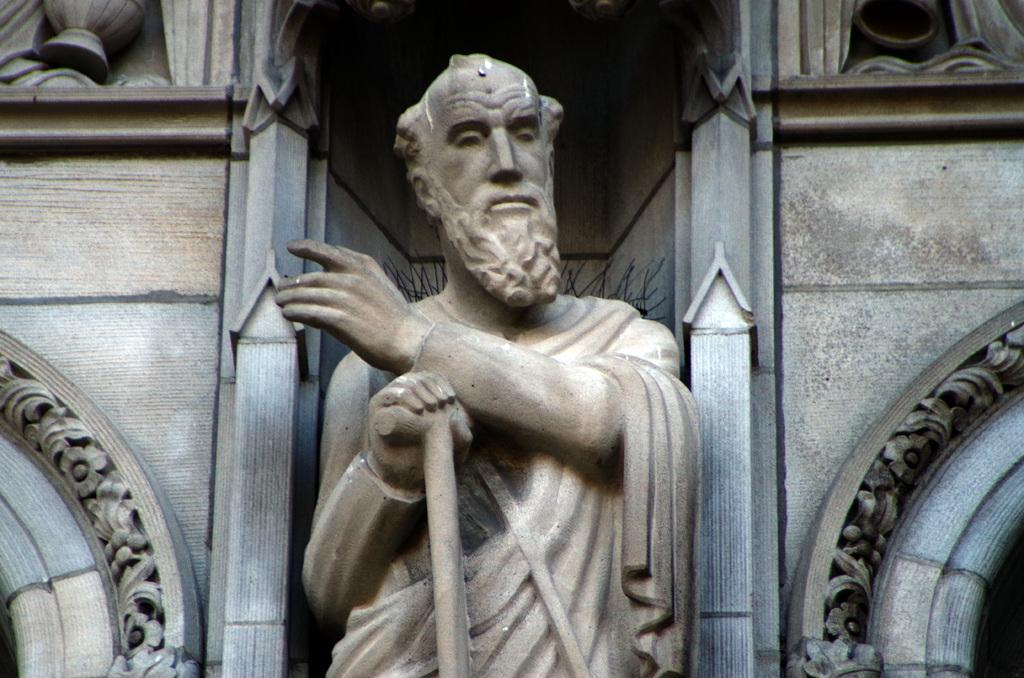What is the main subject in the center of the image? There is a statue in the center of the image. What can be seen in the background of the image? There is a wall in the background of the image. Can you describe the design on the wall in the image? There is a design on the wall on the right side of the image. What is the weight of the bun on the statue's head in the image? There is no bun present on the statue's head in the image. What caused the damage to the statue in the image? There is no damage visible on the statue in the image, and therefore no cause can be determined. 